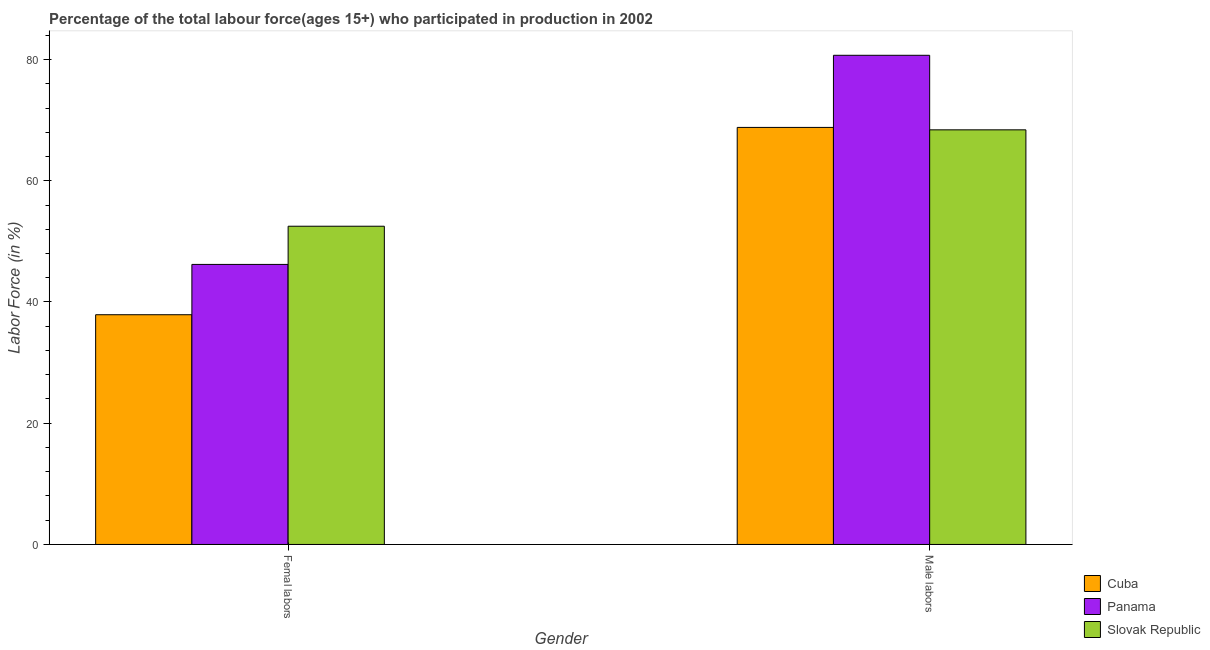What is the label of the 2nd group of bars from the left?
Provide a succinct answer. Male labors. What is the percentage of male labour force in Panama?
Provide a succinct answer. 80.7. Across all countries, what is the maximum percentage of male labour force?
Your answer should be compact. 80.7. Across all countries, what is the minimum percentage of male labour force?
Give a very brief answer. 68.4. In which country was the percentage of male labour force maximum?
Ensure brevity in your answer.  Panama. In which country was the percentage of female labor force minimum?
Your response must be concise. Cuba. What is the total percentage of male labour force in the graph?
Ensure brevity in your answer.  217.9. What is the difference between the percentage of female labor force in Panama and that in Cuba?
Provide a short and direct response. 8.3. What is the difference between the percentage of male labour force in Panama and the percentage of female labor force in Cuba?
Provide a short and direct response. 42.8. What is the average percentage of male labour force per country?
Ensure brevity in your answer.  72.63. What is the difference between the percentage of female labor force and percentage of male labour force in Slovak Republic?
Provide a short and direct response. -15.9. In how many countries, is the percentage of female labor force greater than 24 %?
Provide a short and direct response. 3. What is the ratio of the percentage of female labor force in Panama to that in Slovak Republic?
Give a very brief answer. 0.88. Is the percentage of male labour force in Slovak Republic less than that in Cuba?
Your answer should be very brief. Yes. In how many countries, is the percentage of female labor force greater than the average percentage of female labor force taken over all countries?
Give a very brief answer. 2. What does the 1st bar from the left in Femal labors represents?
Provide a short and direct response. Cuba. What does the 3rd bar from the right in Male labors represents?
Ensure brevity in your answer.  Cuba. How many bars are there?
Provide a short and direct response. 6. What is the difference between two consecutive major ticks on the Y-axis?
Provide a succinct answer. 20. Are the values on the major ticks of Y-axis written in scientific E-notation?
Offer a terse response. No. Does the graph contain grids?
Make the answer very short. No. How many legend labels are there?
Your answer should be compact. 3. How are the legend labels stacked?
Make the answer very short. Vertical. What is the title of the graph?
Offer a terse response. Percentage of the total labour force(ages 15+) who participated in production in 2002. Does "Central African Republic" appear as one of the legend labels in the graph?
Offer a terse response. No. What is the label or title of the X-axis?
Give a very brief answer. Gender. What is the Labor Force (in %) of Cuba in Femal labors?
Offer a terse response. 37.9. What is the Labor Force (in %) in Panama in Femal labors?
Keep it short and to the point. 46.2. What is the Labor Force (in %) of Slovak Republic in Femal labors?
Give a very brief answer. 52.5. What is the Labor Force (in %) of Cuba in Male labors?
Give a very brief answer. 68.8. What is the Labor Force (in %) in Panama in Male labors?
Keep it short and to the point. 80.7. What is the Labor Force (in %) in Slovak Republic in Male labors?
Keep it short and to the point. 68.4. Across all Gender, what is the maximum Labor Force (in %) in Cuba?
Keep it short and to the point. 68.8. Across all Gender, what is the maximum Labor Force (in %) in Panama?
Keep it short and to the point. 80.7. Across all Gender, what is the maximum Labor Force (in %) in Slovak Republic?
Provide a short and direct response. 68.4. Across all Gender, what is the minimum Labor Force (in %) of Cuba?
Give a very brief answer. 37.9. Across all Gender, what is the minimum Labor Force (in %) of Panama?
Your response must be concise. 46.2. Across all Gender, what is the minimum Labor Force (in %) of Slovak Republic?
Your answer should be very brief. 52.5. What is the total Labor Force (in %) of Cuba in the graph?
Make the answer very short. 106.7. What is the total Labor Force (in %) of Panama in the graph?
Ensure brevity in your answer.  126.9. What is the total Labor Force (in %) of Slovak Republic in the graph?
Provide a short and direct response. 120.9. What is the difference between the Labor Force (in %) of Cuba in Femal labors and that in Male labors?
Keep it short and to the point. -30.9. What is the difference between the Labor Force (in %) of Panama in Femal labors and that in Male labors?
Provide a short and direct response. -34.5. What is the difference between the Labor Force (in %) in Slovak Republic in Femal labors and that in Male labors?
Keep it short and to the point. -15.9. What is the difference between the Labor Force (in %) in Cuba in Femal labors and the Labor Force (in %) in Panama in Male labors?
Your answer should be compact. -42.8. What is the difference between the Labor Force (in %) of Cuba in Femal labors and the Labor Force (in %) of Slovak Republic in Male labors?
Keep it short and to the point. -30.5. What is the difference between the Labor Force (in %) of Panama in Femal labors and the Labor Force (in %) of Slovak Republic in Male labors?
Ensure brevity in your answer.  -22.2. What is the average Labor Force (in %) in Cuba per Gender?
Provide a short and direct response. 53.35. What is the average Labor Force (in %) in Panama per Gender?
Your response must be concise. 63.45. What is the average Labor Force (in %) in Slovak Republic per Gender?
Ensure brevity in your answer.  60.45. What is the difference between the Labor Force (in %) of Cuba and Labor Force (in %) of Panama in Femal labors?
Offer a terse response. -8.3. What is the difference between the Labor Force (in %) of Cuba and Labor Force (in %) of Slovak Republic in Femal labors?
Your answer should be compact. -14.6. What is the difference between the Labor Force (in %) in Cuba and Labor Force (in %) in Panama in Male labors?
Ensure brevity in your answer.  -11.9. What is the difference between the Labor Force (in %) of Panama and Labor Force (in %) of Slovak Republic in Male labors?
Your answer should be very brief. 12.3. What is the ratio of the Labor Force (in %) of Cuba in Femal labors to that in Male labors?
Your answer should be very brief. 0.55. What is the ratio of the Labor Force (in %) of Panama in Femal labors to that in Male labors?
Make the answer very short. 0.57. What is the ratio of the Labor Force (in %) in Slovak Republic in Femal labors to that in Male labors?
Your response must be concise. 0.77. What is the difference between the highest and the second highest Labor Force (in %) of Cuba?
Keep it short and to the point. 30.9. What is the difference between the highest and the second highest Labor Force (in %) of Panama?
Your answer should be compact. 34.5. What is the difference between the highest and the second highest Labor Force (in %) in Slovak Republic?
Offer a very short reply. 15.9. What is the difference between the highest and the lowest Labor Force (in %) of Cuba?
Keep it short and to the point. 30.9. What is the difference between the highest and the lowest Labor Force (in %) in Panama?
Keep it short and to the point. 34.5. What is the difference between the highest and the lowest Labor Force (in %) of Slovak Republic?
Your answer should be very brief. 15.9. 